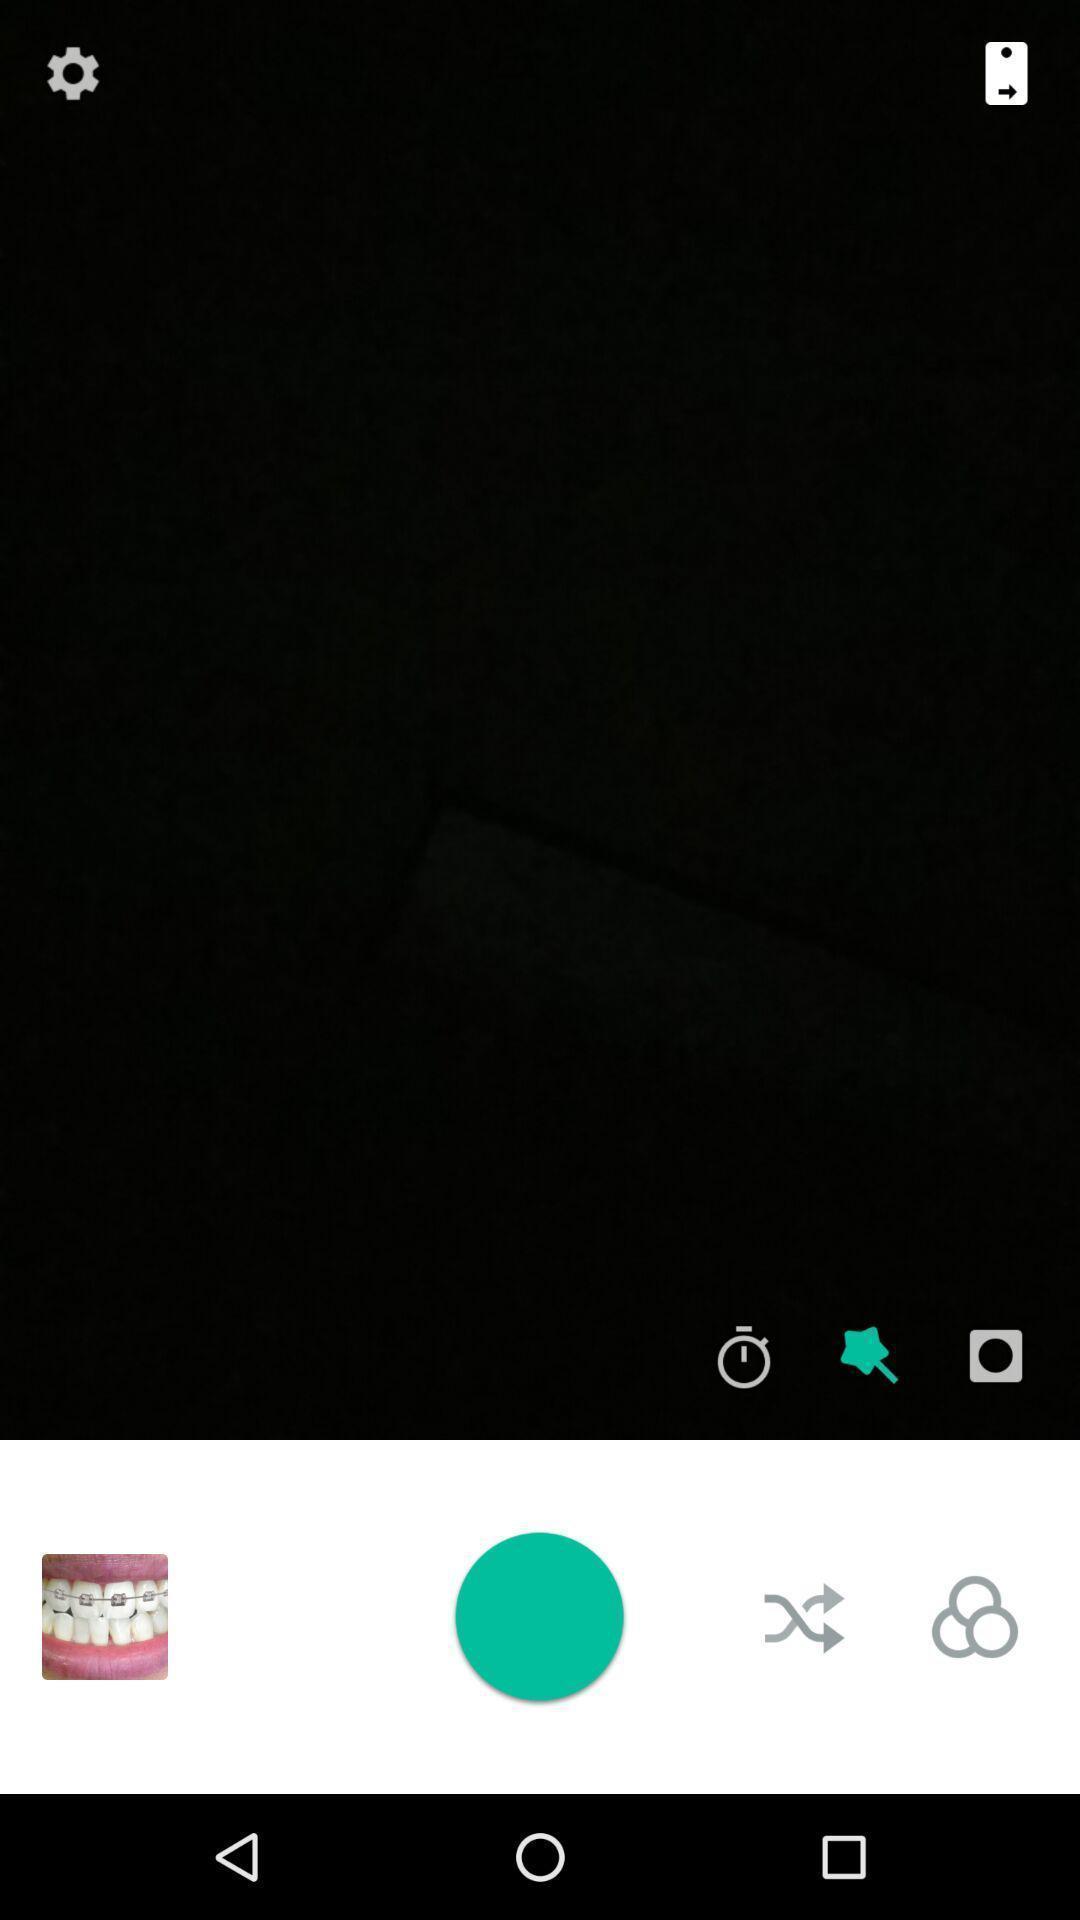Describe the key features of this screenshot. Screen page displaying various options in camera application. 